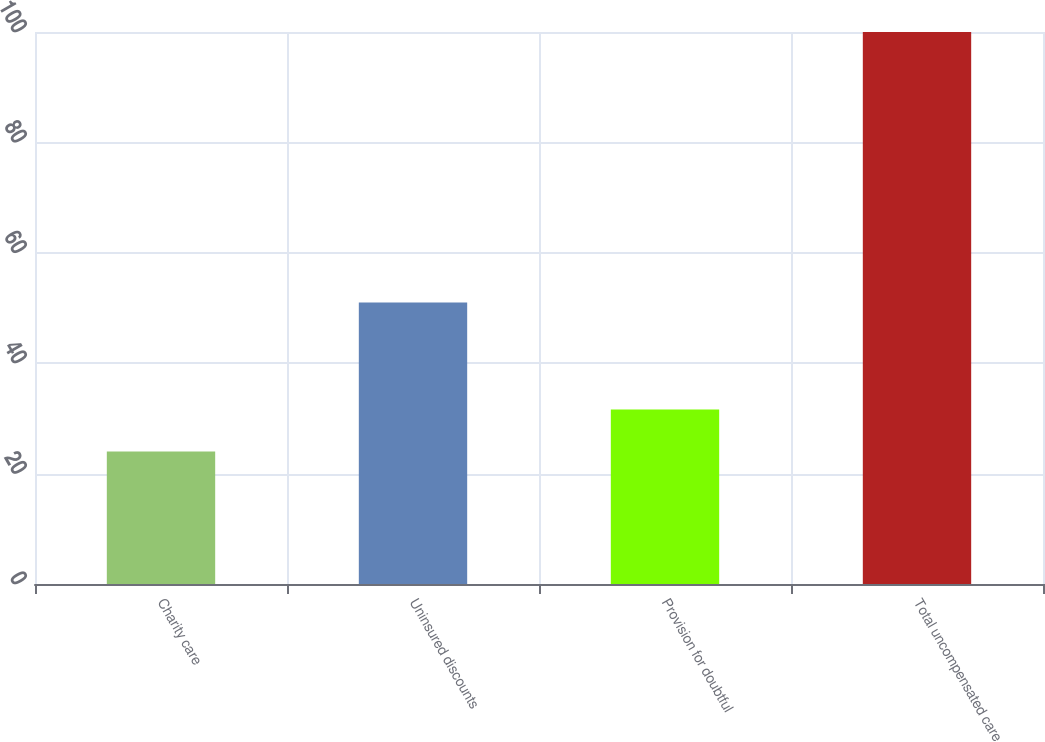<chart> <loc_0><loc_0><loc_500><loc_500><bar_chart><fcel>Charity care<fcel>Uninsured discounts<fcel>Provision for doubtful<fcel>Total uncompensated care<nl><fcel>24<fcel>51<fcel>31.6<fcel>100<nl></chart> 